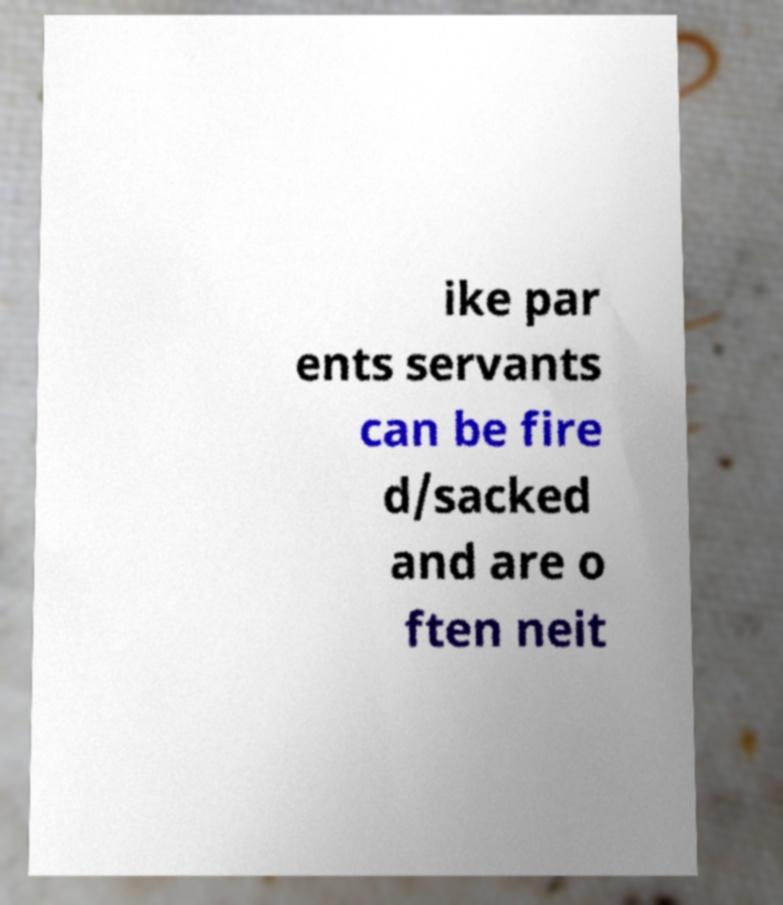Could you extract and type out the text from this image? ike par ents servants can be fire d/sacked and are o ften neit 